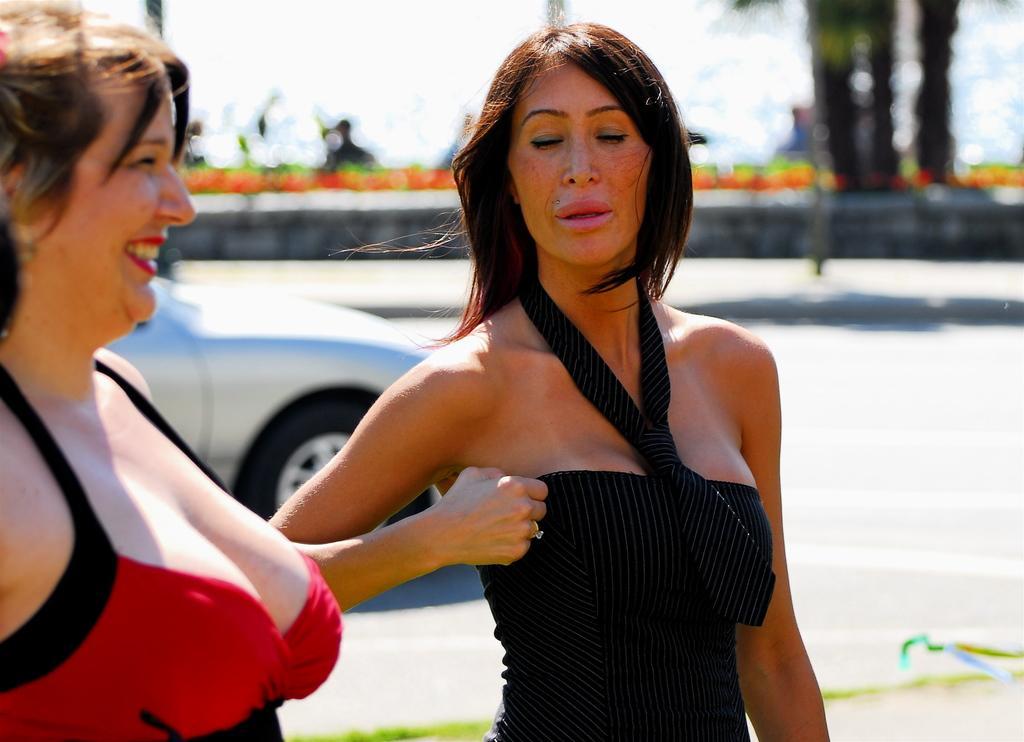How would you summarize this image in a sentence or two? In this picture we can see two women standing, a woman on the left side is smiling, in the background there is a car, we can see a blurry background. 